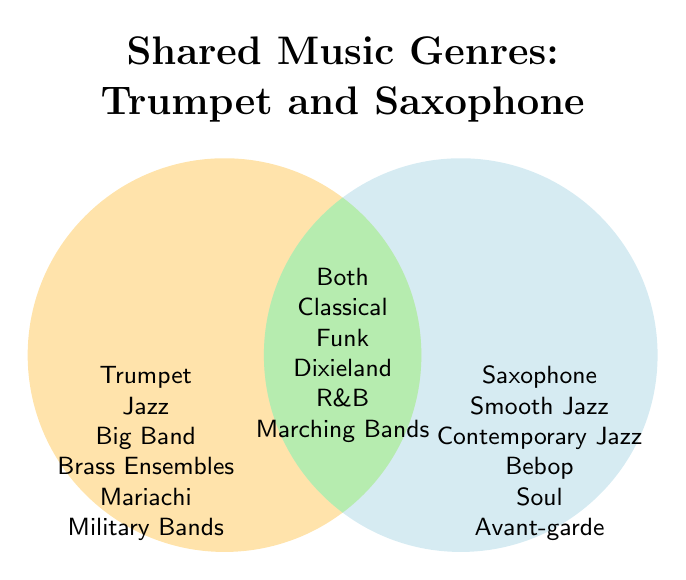What is the genre listed only for the trumpet? The genre only for the trumpet is in the left circle, which includes Jazz, Big Band, Brass Ensembles, Mariachi, and Military Bands.
Answer: Jazz, Big Band, Brass Ensembles, Mariachi, Military Bands Which genres are common to both trumpet and saxophone? The genres common to both instruments are listed in the overlapping section of the Venn diagram.
Answer: Classical, Funk, Dixieland, R&B, Marching Bands What is the total number of genres listed in the diagram? The trumpet has 5 unique genres, the saxophone has 5 unique genres, and there are 5 shared genres. Therefore, the total is 5 + 5 + 5.
Answer: 15 Compare the number of unique genres for trumpet and saxophone. Which instrument has more? Count the unique genres for each: the trumpet has 5 and the saxophone has 5. They have an equal number of unique genres.
Answer: Equal Are there more genres shared between both instruments or unique to each? There are 5 shared genres. Each instrument also has 5 unique genres. Since 5 is equal to 5, the number of shared genres and unique genres is the same.
Answer: Equal What genres specific to saxophone do not overlap with trumpet genres? The genres unique to the saxophone are listed in the right circle, which includes Smooth Jazz, Contemporary Jazz, Bebop, Soul, and Avant-garde.
Answer: Smooth Jazz, Contemporary Jazz, Bebop, Soul, Avant-garde How many genres are either specific to the trumpet or shared with the saxophone? Add the unique trumpet genres (5) to the shared genres (5): 5 + 5 = 10 genres.
Answer: 10 What is the color representing the shared genres? The shared genre section is where the two circles overlap and is colored in light green.
Answer: Light green 